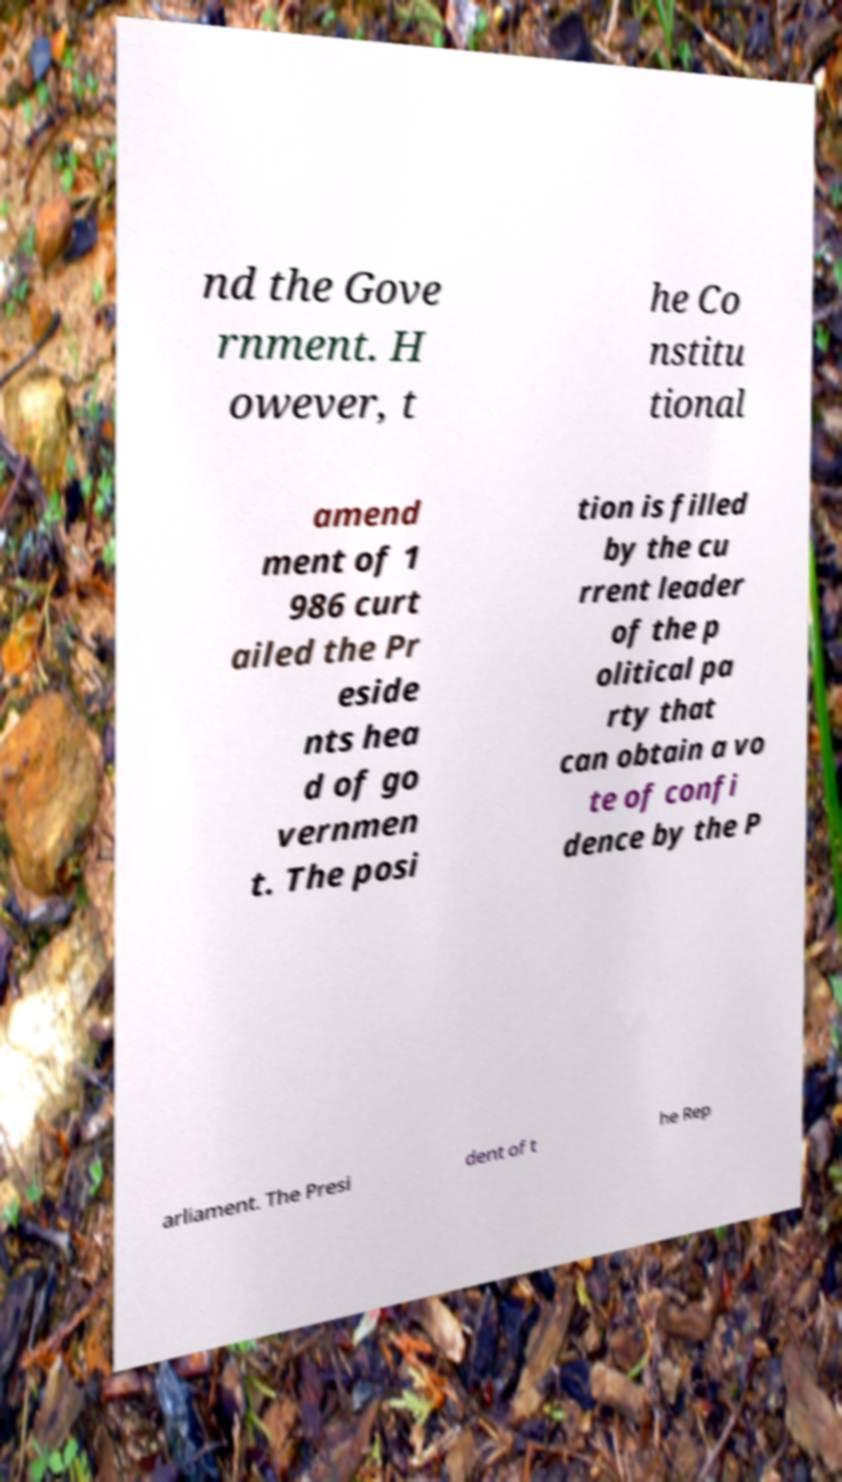Could you extract and type out the text from this image? nd the Gove rnment. H owever, t he Co nstitu tional amend ment of 1 986 curt ailed the Pr eside nts hea d of go vernmen t. The posi tion is filled by the cu rrent leader of the p olitical pa rty that can obtain a vo te of confi dence by the P arliament. The Presi dent of t he Rep 